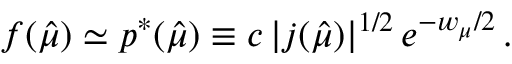Convert formula to latex. <formula><loc_0><loc_0><loc_500><loc_500>f ( \hat { \mu } ) \simeq p ^ { \ast } ( \hat { \mu } ) \equiv c \, | j ( \hat { \mu } ) | ^ { 1 / 2 } \, e ^ { - w _ { \mu } / 2 } \, .</formula> 